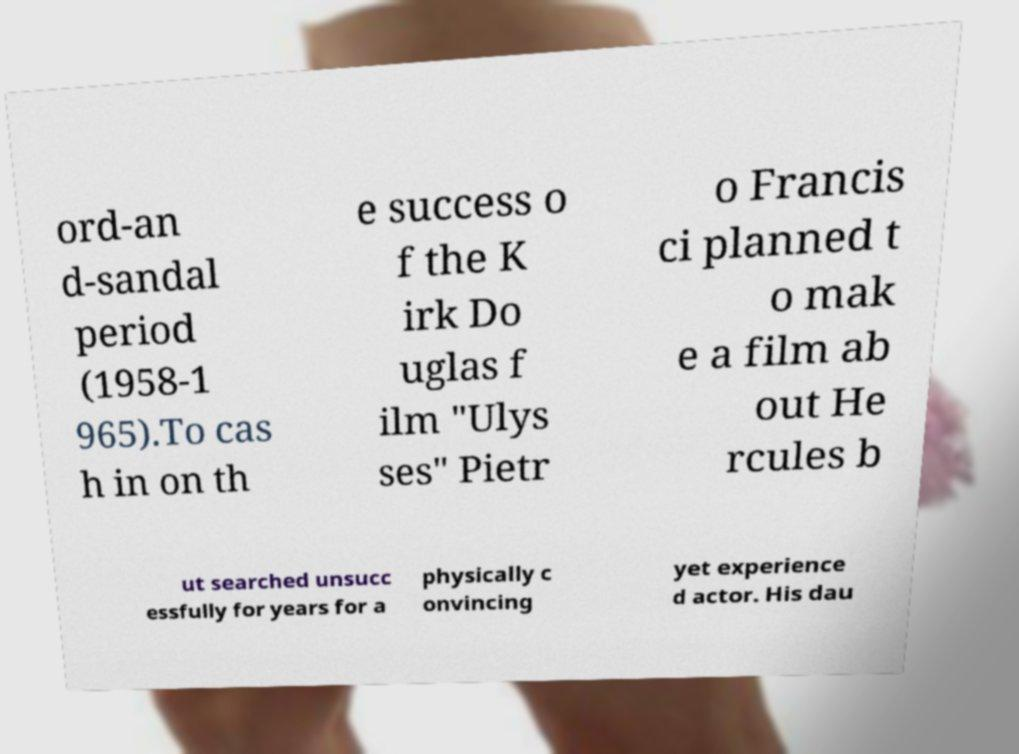Please read and relay the text visible in this image. What does it say? ord-an d-sandal period (1958-1 965).To cas h in on th e success o f the K irk Do uglas f ilm "Ulys ses" Pietr o Francis ci planned t o mak e a film ab out He rcules b ut searched unsucc essfully for years for a physically c onvincing yet experience d actor. His dau 